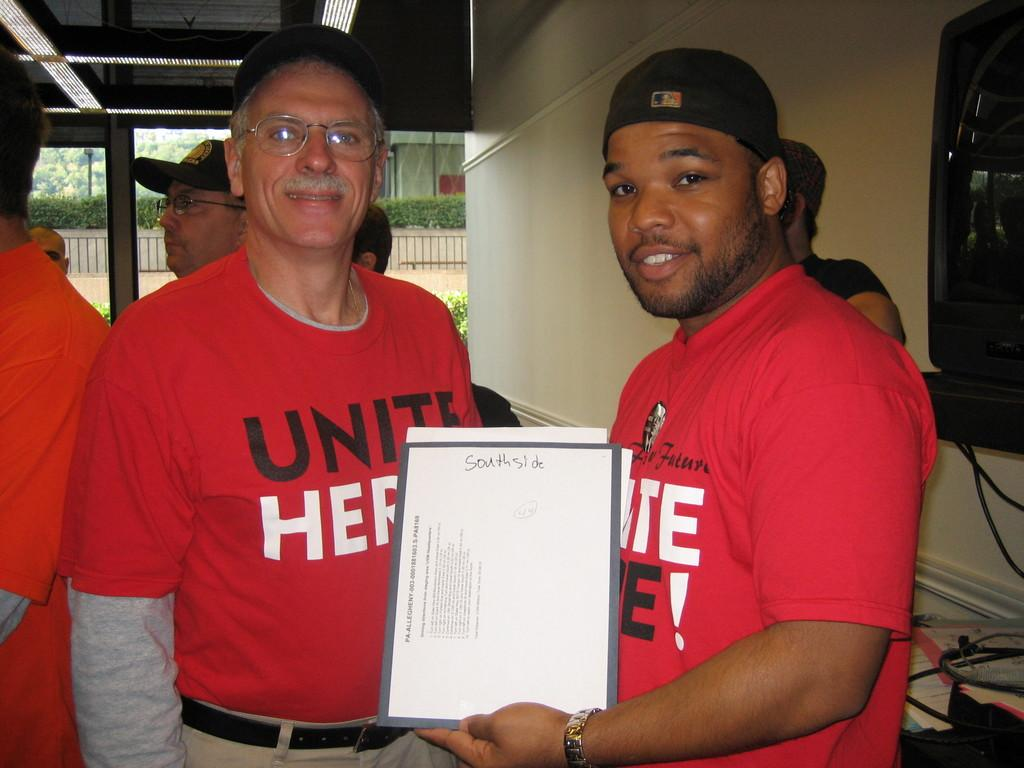<image>
Summarize the visual content of the image. A man holding a document that says Southside written in pen on it 